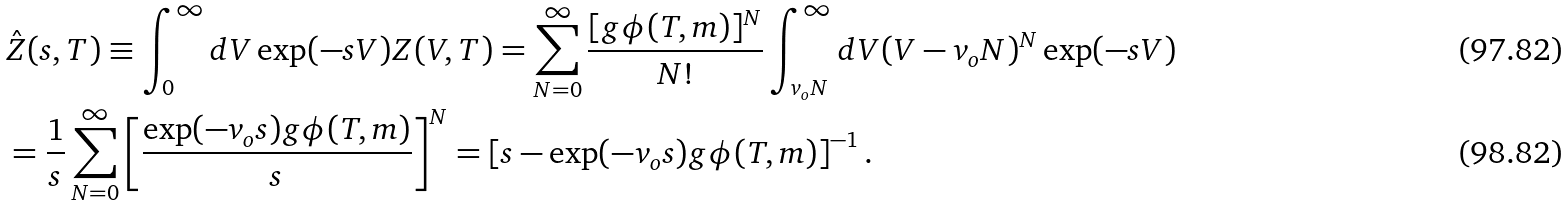<formula> <loc_0><loc_0><loc_500><loc_500>& \hat { Z } ( s , T ) \equiv \int _ { 0 } ^ { \infty } d V \exp ( - s V ) Z ( V , T ) = \sum _ { N = 0 } ^ { \infty } \frac { [ g \phi ( T , m ) ] ^ { N } } { N ! } \int _ { v _ { o } N } ^ { \infty } d V ( V - v _ { o } N ) ^ { N } \exp ( - s V ) \\ & = \frac { 1 } { s } \sum _ { N = 0 } ^ { \infty } \left [ \frac { \exp ( - v _ { o } s ) g \phi ( T , m ) } { s } \right ] ^ { N } = \left [ s - \exp ( - v _ { o } s ) g \phi ( T , m ) \right ] ^ { - 1 } .</formula> 